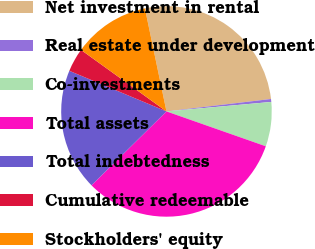Convert chart to OTSL. <chart><loc_0><loc_0><loc_500><loc_500><pie_chart><fcel>Net investment in rental<fcel>Real estate under development<fcel>Co-investments<fcel>Total assets<fcel>Total indebtedness<fcel>Cumulative redeemable<fcel>Stockholders' equity<nl><fcel>26.4%<fcel>0.45%<fcel>6.81%<fcel>32.24%<fcel>18.69%<fcel>3.63%<fcel>11.79%<nl></chart> 